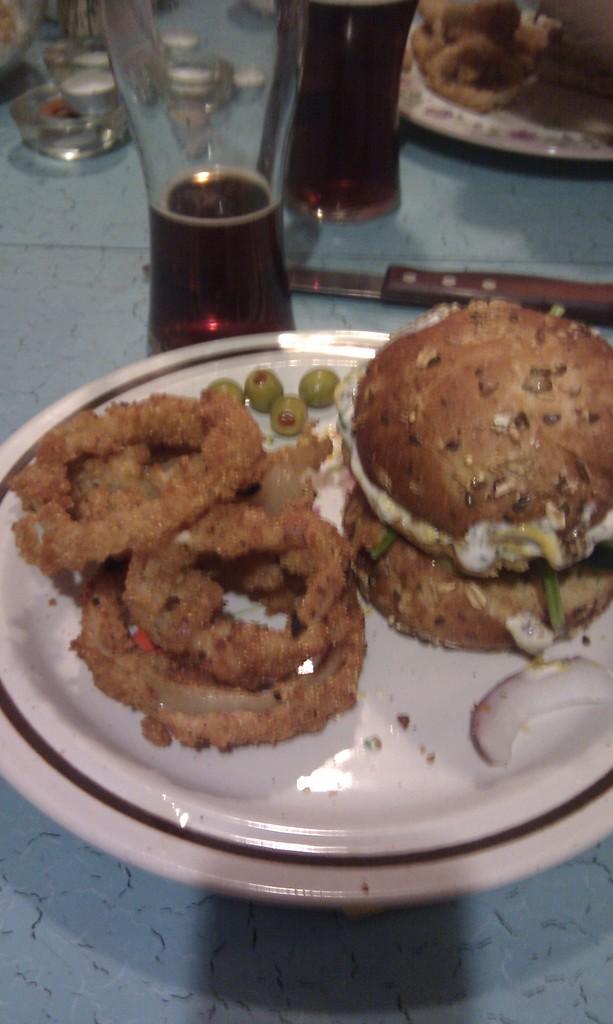Could you give a brief overview of what you see in this image? In this image, we can see food on the plates that are placed on the blue surface. Here we can see glasses with liquid, some objects and knife. 